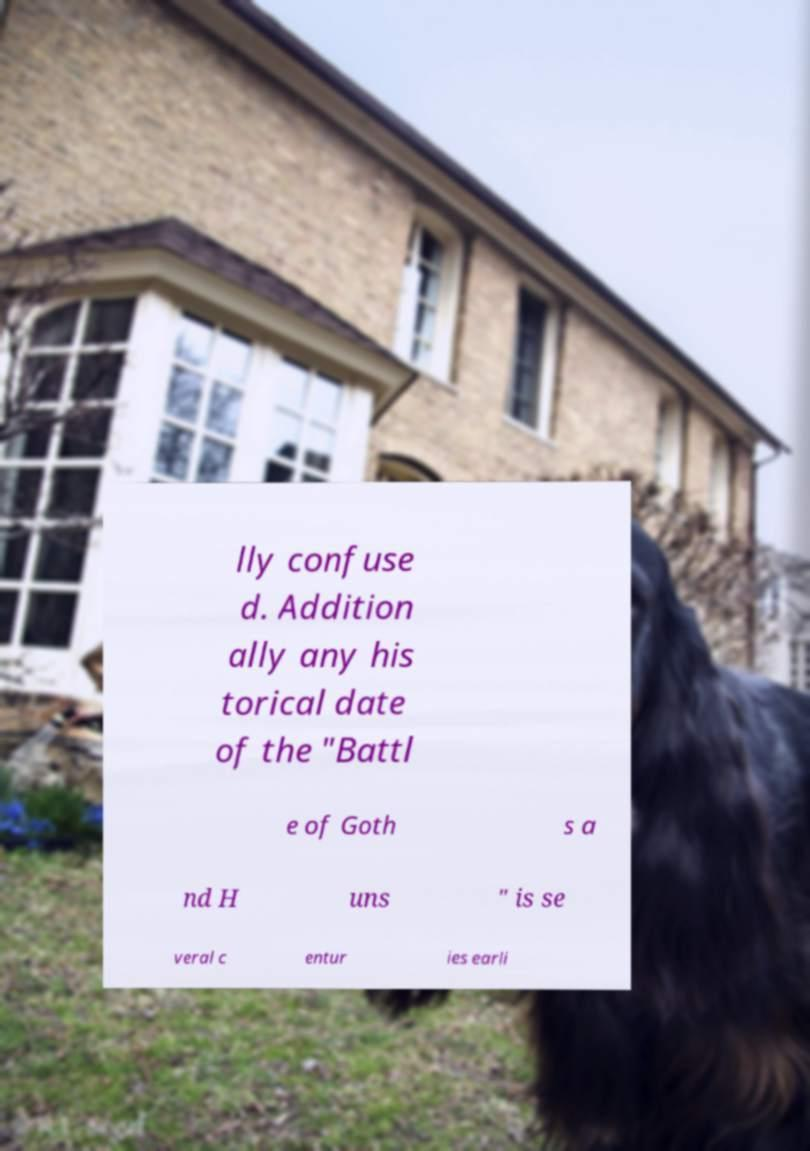I need the written content from this picture converted into text. Can you do that? lly confuse d. Addition ally any his torical date of the "Battl e of Goth s a nd H uns " is se veral c entur ies earli 